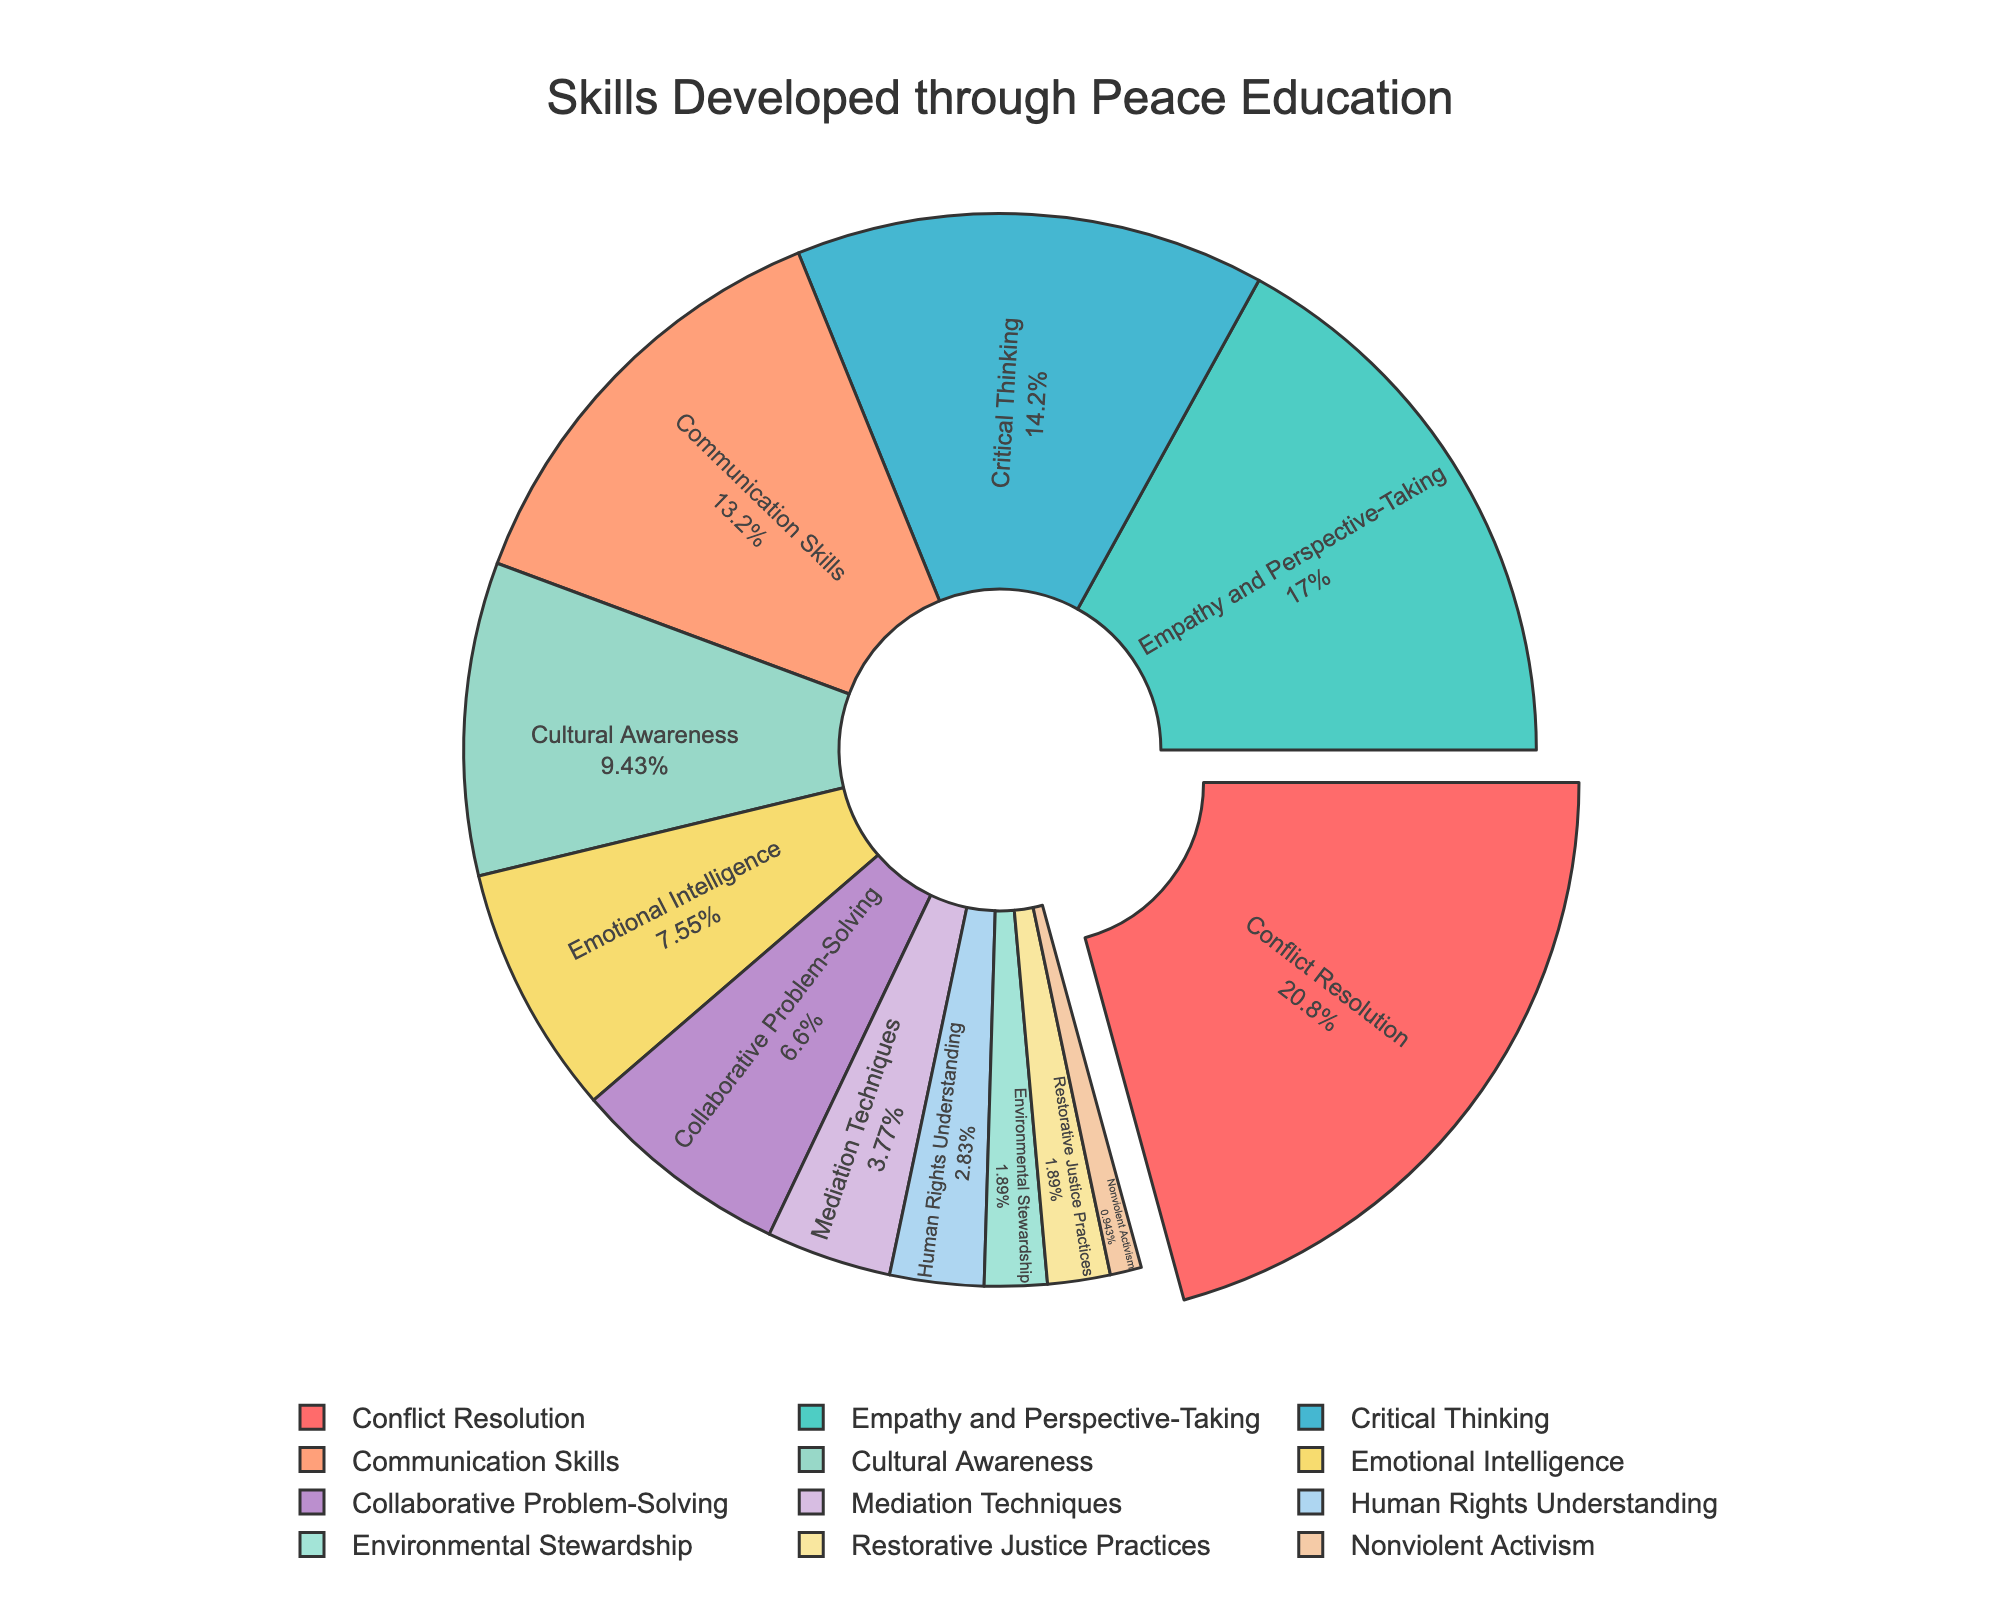What percentage of the skills developed through peace education are related to Conflict Resolution? Refer to the section labeled "Conflict Resolution" on the pie chart and note its percentage value.
Answer: 22% Which skill category has the smallest percentage, and what is that percentage? Identify the smallest slice on the pie chart, which is labeled "Nonviolent Activism" and note its percentage value.
Answer: Nonviolent Activism, 1% What is the combined percentage of Emotional Intelligence and Environmental Stewardship skills? Find the percentage values for Emotional Intelligence (8%) and Environmental Stewardship (2%) and add them together: 8% + 2% = 10%.
Answer: 10% How does the percentage of Empathy and Perspective-Taking compare to that of Critical Thinking? Compare the percentage values for Empathy and Perspective-Taking (18%) and Critical Thinking (15%). Empathy and Perspective-Taking has a higher percentage.
Answer: Empathy and Perspective-Taking is higher What is the total percentage of skills that relate to problem-solving (Collaborative Problem-Solving and Mediation Techniques)? Sum the percentage values for Collaborative Problem-Solving (7%) and Mediation Techniques (4%): 7% + 4% = 11%.
Answer: 11% Which skill category is represented by the blue section on the pie chart, and what is its percentage? Identify the blue section on the pie chart and note that it corresponds to "Empathy and Perspective-Taking" with a percentage of 18%.
Answer: Empathy and Perspective-Taking, 18% Is the percentage of skills related to Communication Skills greater or less than that of Cultural Awareness? Compare the percentage values for Communication Skills (14%) and Cultural Awareness (10%). Communication Skills has a higher percentage.
Answer: Greater What is the total percentage of the top 3 skill categories combined? Identify the top 3 sectors by looking at their sizes: Conflict Resolution (22%), Empathy and Perspective-Taking (18%), and Critical Thinking (15%). Sum these values: 22% + 18% + 15% = 55%.
Answer: 55% What is the percentage difference between Communication Skills and Mediation Techniques? Find the percentage values for Communication Skills (14%) and Mediation Techniques (4%) and calculate the difference: 14% - 4% = 10%.
Answer: 10% How many skills categories have a percentage less than or equal to 5%? Identify the slices with percentages 5% or less, which are Mediation Techniques (4%), Human Rights Understanding (3%), Environmental Stewardship (2%), Restorative Justice Practices (2%), and Nonviolent Activism (1%). There are 5 such categories.
Answer: 5 